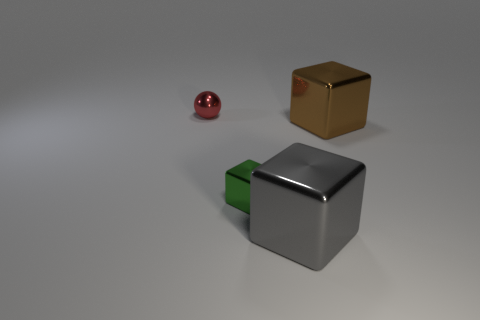Is there a green thing of the same size as the brown shiny thing?
Keep it short and to the point. No. What number of other objects have the same shape as the gray shiny thing?
Your answer should be compact. 2. Are there the same number of tiny red objects in front of the red shiny ball and green shiny things that are behind the small green metal thing?
Provide a short and direct response. Yes. Are any big gray metal cubes visible?
Your answer should be compact. Yes. What is the size of the sphere behind the large shiny cube behind the small thing that is to the right of the sphere?
Ensure brevity in your answer.  Small. What is the shape of the green thing that is the same size as the red ball?
Your response must be concise. Cube. Is there anything else that is the same material as the large brown thing?
Your answer should be compact. Yes. What number of objects are either metallic cubes on the left side of the gray metallic block or brown things?
Your answer should be very brief. 2. Are there any tiny metallic things that are on the right side of the red ball that is to the left of the small metal object in front of the sphere?
Your answer should be very brief. Yes. What number of large gray balls are there?
Your answer should be compact. 0. 